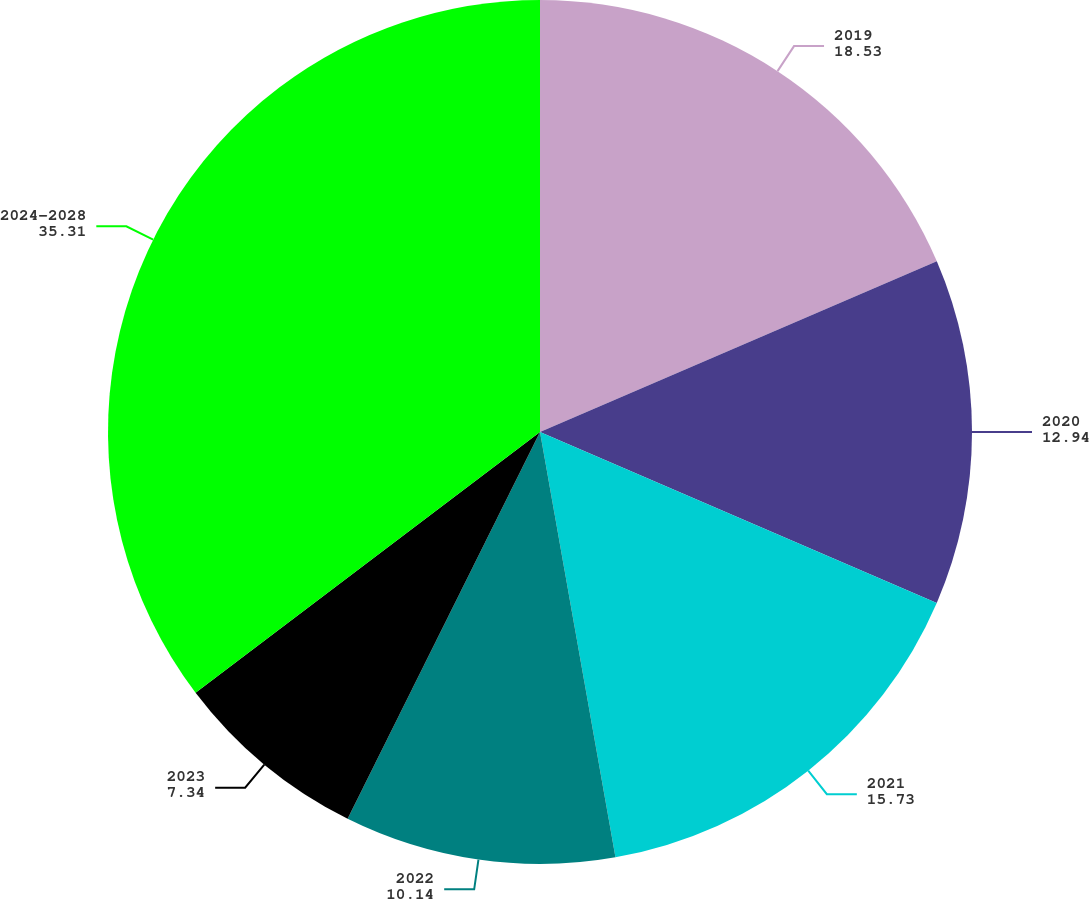Convert chart. <chart><loc_0><loc_0><loc_500><loc_500><pie_chart><fcel>2019<fcel>2020<fcel>2021<fcel>2022<fcel>2023<fcel>2024-2028<nl><fcel>18.53%<fcel>12.94%<fcel>15.73%<fcel>10.14%<fcel>7.34%<fcel>35.31%<nl></chart> 